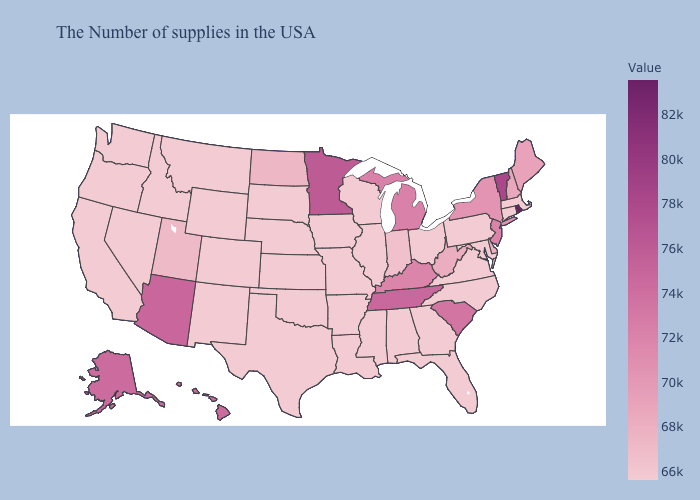Does North Dakota have the lowest value in the USA?
Keep it brief. No. Among the states that border Ohio , which have the lowest value?
Give a very brief answer. Pennsylvania. Which states hav the highest value in the West?
Write a very short answer. Arizona. Does the map have missing data?
Answer briefly. No. Does the map have missing data?
Short answer required. No. Among the states that border Kentucky , which have the lowest value?
Be succinct. Ohio, Illinois, Missouri. Among the states that border Missouri , which have the lowest value?
Short answer required. Illinois, Arkansas, Iowa, Kansas, Nebraska, Oklahoma. 